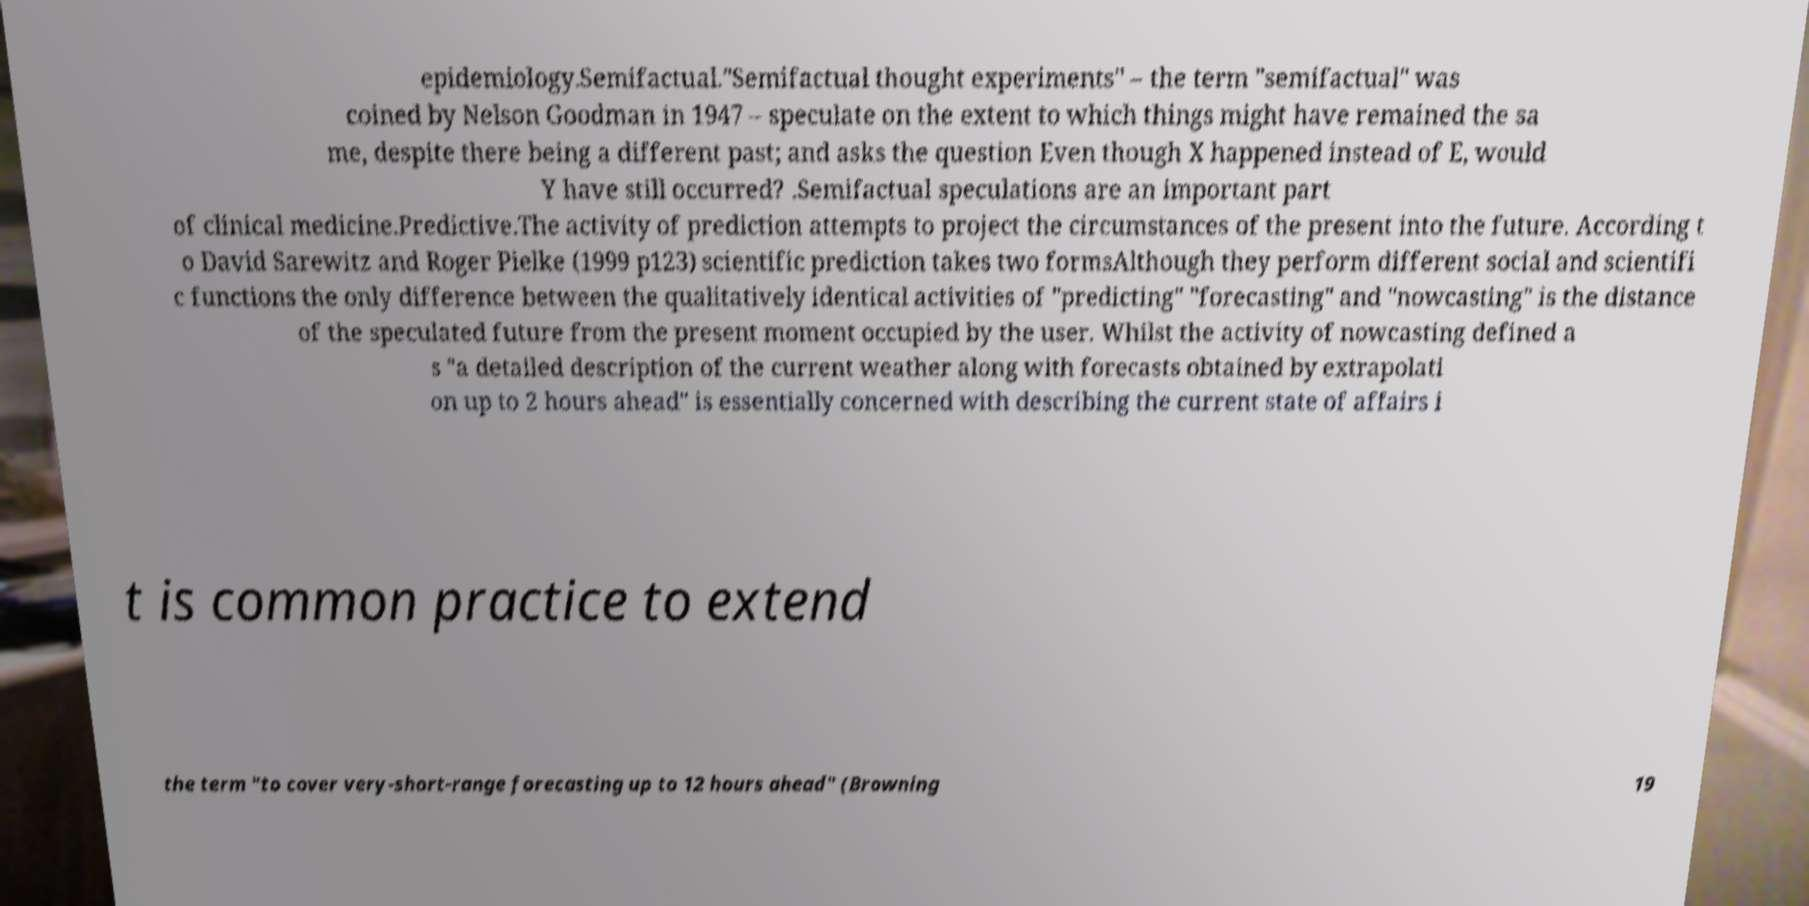I need the written content from this picture converted into text. Can you do that? epidemiology.Semifactual."Semifactual thought experiments" – the term "semifactual" was coined by Nelson Goodman in 1947 – speculate on the extent to which things might have remained the sa me, despite there being a different past; and asks the question Even though X happened instead of E, would Y have still occurred? .Semifactual speculations are an important part of clinical medicine.Predictive.The activity of prediction attempts to project the circumstances of the present into the future. According t o David Sarewitz and Roger Pielke (1999 p123) scientific prediction takes two formsAlthough they perform different social and scientifi c functions the only difference between the qualitatively identical activities of "predicting" "forecasting" and "nowcasting" is the distance of the speculated future from the present moment occupied by the user. Whilst the activity of nowcasting defined a s "a detailed description of the current weather along with forecasts obtained by extrapolati on up to 2 hours ahead" is essentially concerned with describing the current state of affairs i t is common practice to extend the term "to cover very-short-range forecasting up to 12 hours ahead" (Browning 19 